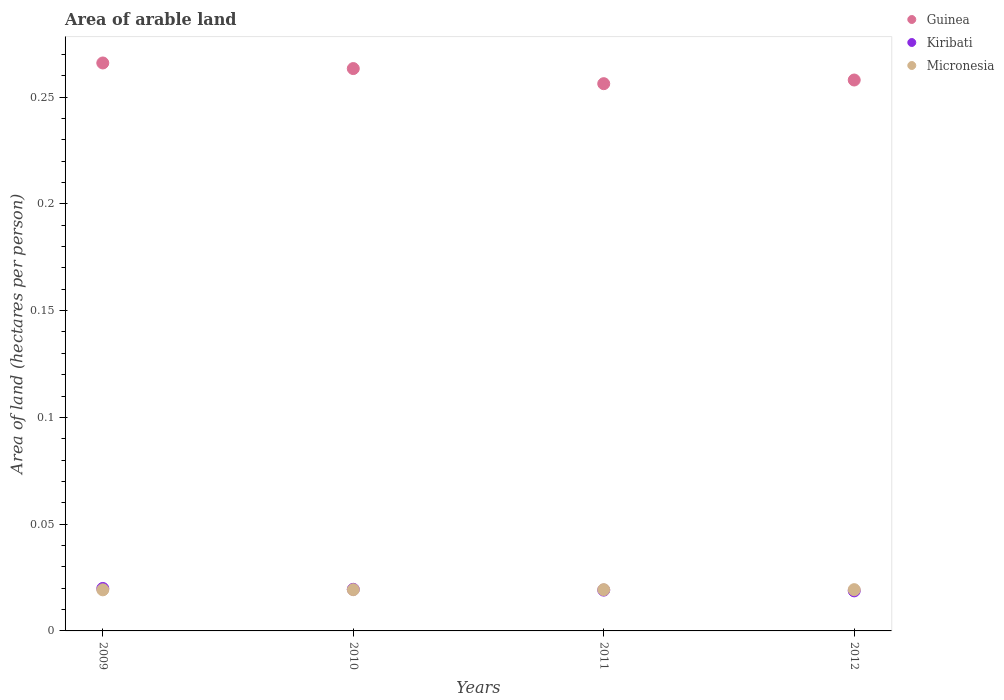Is the number of dotlines equal to the number of legend labels?
Offer a very short reply. Yes. What is the total arable land in Micronesia in 2012?
Your answer should be very brief. 0.02. Across all years, what is the maximum total arable land in Kiribati?
Keep it short and to the point. 0.02. Across all years, what is the minimum total arable land in Kiribati?
Offer a very short reply. 0.02. What is the total total arable land in Guinea in the graph?
Make the answer very short. 1.04. What is the difference between the total arable land in Micronesia in 2010 and that in 2011?
Provide a succinct answer. -2.667392982479838e-5. What is the difference between the total arable land in Micronesia in 2011 and the total arable land in Kiribati in 2012?
Provide a succinct answer. 0. What is the average total arable land in Guinea per year?
Keep it short and to the point. 0.26. In the year 2010, what is the difference between the total arable land in Micronesia and total arable land in Guinea?
Your response must be concise. -0.24. What is the ratio of the total arable land in Micronesia in 2010 to that in 2012?
Your answer should be very brief. 1. What is the difference between the highest and the second highest total arable land in Kiribati?
Provide a succinct answer. 0. What is the difference between the highest and the lowest total arable land in Kiribati?
Give a very brief answer. 0. Is the sum of the total arable land in Guinea in 2010 and 2011 greater than the maximum total arable land in Kiribati across all years?
Give a very brief answer. Yes. Is it the case that in every year, the sum of the total arable land in Kiribati and total arable land in Guinea  is greater than the total arable land in Micronesia?
Your response must be concise. Yes. Is the total arable land in Guinea strictly less than the total arable land in Kiribati over the years?
Ensure brevity in your answer.  No. How many years are there in the graph?
Offer a very short reply. 4. What is the difference between two consecutive major ticks on the Y-axis?
Keep it short and to the point. 0.05. Does the graph contain any zero values?
Offer a very short reply. No. Does the graph contain grids?
Offer a very short reply. No. How many legend labels are there?
Provide a short and direct response. 3. What is the title of the graph?
Your answer should be compact. Area of arable land. Does "Chile" appear as one of the legend labels in the graph?
Keep it short and to the point. No. What is the label or title of the Y-axis?
Your answer should be compact. Area of land (hectares per person). What is the Area of land (hectares per person) of Guinea in 2009?
Provide a succinct answer. 0.27. What is the Area of land (hectares per person) of Kiribati in 2009?
Ensure brevity in your answer.  0.02. What is the Area of land (hectares per person) in Micronesia in 2009?
Provide a succinct answer. 0.02. What is the Area of land (hectares per person) in Guinea in 2010?
Make the answer very short. 0.26. What is the Area of land (hectares per person) in Kiribati in 2010?
Provide a succinct answer. 0.02. What is the Area of land (hectares per person) of Micronesia in 2010?
Keep it short and to the point. 0.02. What is the Area of land (hectares per person) in Guinea in 2011?
Your answer should be very brief. 0.26. What is the Area of land (hectares per person) of Kiribati in 2011?
Provide a short and direct response. 0.02. What is the Area of land (hectares per person) in Micronesia in 2011?
Ensure brevity in your answer.  0.02. What is the Area of land (hectares per person) in Guinea in 2012?
Offer a terse response. 0.26. What is the Area of land (hectares per person) of Kiribati in 2012?
Provide a short and direct response. 0.02. What is the Area of land (hectares per person) in Micronesia in 2012?
Make the answer very short. 0.02. Across all years, what is the maximum Area of land (hectares per person) of Guinea?
Your answer should be very brief. 0.27. Across all years, what is the maximum Area of land (hectares per person) in Kiribati?
Your answer should be compact. 0.02. Across all years, what is the maximum Area of land (hectares per person) of Micronesia?
Give a very brief answer. 0.02. Across all years, what is the minimum Area of land (hectares per person) in Guinea?
Your answer should be compact. 0.26. Across all years, what is the minimum Area of land (hectares per person) of Kiribati?
Provide a succinct answer. 0.02. Across all years, what is the minimum Area of land (hectares per person) in Micronesia?
Keep it short and to the point. 0.02. What is the total Area of land (hectares per person) in Guinea in the graph?
Provide a short and direct response. 1.04. What is the total Area of land (hectares per person) of Kiribati in the graph?
Give a very brief answer. 0.08. What is the total Area of land (hectares per person) in Micronesia in the graph?
Ensure brevity in your answer.  0.08. What is the difference between the Area of land (hectares per person) in Guinea in 2009 and that in 2010?
Provide a succinct answer. 0. What is the difference between the Area of land (hectares per person) of Micronesia in 2009 and that in 2010?
Provide a short and direct response. -0. What is the difference between the Area of land (hectares per person) in Guinea in 2009 and that in 2011?
Offer a terse response. 0.01. What is the difference between the Area of land (hectares per person) of Kiribati in 2009 and that in 2011?
Your answer should be compact. 0. What is the difference between the Area of land (hectares per person) in Micronesia in 2009 and that in 2011?
Provide a short and direct response. -0. What is the difference between the Area of land (hectares per person) in Guinea in 2009 and that in 2012?
Offer a terse response. 0.01. What is the difference between the Area of land (hectares per person) in Kiribati in 2009 and that in 2012?
Provide a short and direct response. 0. What is the difference between the Area of land (hectares per person) in Micronesia in 2009 and that in 2012?
Your response must be concise. -0. What is the difference between the Area of land (hectares per person) of Guinea in 2010 and that in 2011?
Keep it short and to the point. 0.01. What is the difference between the Area of land (hectares per person) of Kiribati in 2010 and that in 2011?
Make the answer very short. 0. What is the difference between the Area of land (hectares per person) in Guinea in 2010 and that in 2012?
Offer a very short reply. 0.01. What is the difference between the Area of land (hectares per person) in Kiribati in 2010 and that in 2012?
Your response must be concise. 0. What is the difference between the Area of land (hectares per person) of Guinea in 2011 and that in 2012?
Your response must be concise. -0. What is the difference between the Area of land (hectares per person) in Kiribati in 2011 and that in 2012?
Provide a succinct answer. 0. What is the difference between the Area of land (hectares per person) of Micronesia in 2011 and that in 2012?
Offer a very short reply. 0. What is the difference between the Area of land (hectares per person) in Guinea in 2009 and the Area of land (hectares per person) in Kiribati in 2010?
Provide a short and direct response. 0.25. What is the difference between the Area of land (hectares per person) of Guinea in 2009 and the Area of land (hectares per person) of Micronesia in 2010?
Your answer should be compact. 0.25. What is the difference between the Area of land (hectares per person) of Kiribati in 2009 and the Area of land (hectares per person) of Micronesia in 2010?
Make the answer very short. 0. What is the difference between the Area of land (hectares per person) in Guinea in 2009 and the Area of land (hectares per person) in Kiribati in 2011?
Give a very brief answer. 0.25. What is the difference between the Area of land (hectares per person) in Guinea in 2009 and the Area of land (hectares per person) in Micronesia in 2011?
Your answer should be compact. 0.25. What is the difference between the Area of land (hectares per person) of Kiribati in 2009 and the Area of land (hectares per person) of Micronesia in 2011?
Provide a succinct answer. 0. What is the difference between the Area of land (hectares per person) in Guinea in 2009 and the Area of land (hectares per person) in Kiribati in 2012?
Provide a succinct answer. 0.25. What is the difference between the Area of land (hectares per person) in Guinea in 2009 and the Area of land (hectares per person) in Micronesia in 2012?
Provide a succinct answer. 0.25. What is the difference between the Area of land (hectares per person) in Kiribati in 2009 and the Area of land (hectares per person) in Micronesia in 2012?
Give a very brief answer. 0. What is the difference between the Area of land (hectares per person) in Guinea in 2010 and the Area of land (hectares per person) in Kiribati in 2011?
Make the answer very short. 0.24. What is the difference between the Area of land (hectares per person) in Guinea in 2010 and the Area of land (hectares per person) in Micronesia in 2011?
Make the answer very short. 0.24. What is the difference between the Area of land (hectares per person) in Guinea in 2010 and the Area of land (hectares per person) in Kiribati in 2012?
Your answer should be compact. 0.24. What is the difference between the Area of land (hectares per person) in Guinea in 2010 and the Area of land (hectares per person) in Micronesia in 2012?
Give a very brief answer. 0.24. What is the difference between the Area of land (hectares per person) in Guinea in 2011 and the Area of land (hectares per person) in Kiribati in 2012?
Give a very brief answer. 0.24. What is the difference between the Area of land (hectares per person) of Guinea in 2011 and the Area of land (hectares per person) of Micronesia in 2012?
Provide a short and direct response. 0.24. What is the difference between the Area of land (hectares per person) in Kiribati in 2011 and the Area of land (hectares per person) in Micronesia in 2012?
Offer a very short reply. -0. What is the average Area of land (hectares per person) in Guinea per year?
Provide a succinct answer. 0.26. What is the average Area of land (hectares per person) in Kiribati per year?
Keep it short and to the point. 0.02. What is the average Area of land (hectares per person) in Micronesia per year?
Provide a short and direct response. 0.02. In the year 2009, what is the difference between the Area of land (hectares per person) of Guinea and Area of land (hectares per person) of Kiribati?
Your response must be concise. 0.25. In the year 2009, what is the difference between the Area of land (hectares per person) in Guinea and Area of land (hectares per person) in Micronesia?
Offer a terse response. 0.25. In the year 2009, what is the difference between the Area of land (hectares per person) of Kiribati and Area of land (hectares per person) of Micronesia?
Provide a short and direct response. 0. In the year 2010, what is the difference between the Area of land (hectares per person) of Guinea and Area of land (hectares per person) of Kiribati?
Ensure brevity in your answer.  0.24. In the year 2010, what is the difference between the Area of land (hectares per person) in Guinea and Area of land (hectares per person) in Micronesia?
Ensure brevity in your answer.  0.24. In the year 2010, what is the difference between the Area of land (hectares per person) of Kiribati and Area of land (hectares per person) of Micronesia?
Provide a succinct answer. 0. In the year 2011, what is the difference between the Area of land (hectares per person) in Guinea and Area of land (hectares per person) in Kiribati?
Provide a short and direct response. 0.24. In the year 2011, what is the difference between the Area of land (hectares per person) of Guinea and Area of land (hectares per person) of Micronesia?
Provide a succinct answer. 0.24. In the year 2011, what is the difference between the Area of land (hectares per person) in Kiribati and Area of land (hectares per person) in Micronesia?
Your answer should be compact. -0. In the year 2012, what is the difference between the Area of land (hectares per person) in Guinea and Area of land (hectares per person) in Kiribati?
Offer a very short reply. 0.24. In the year 2012, what is the difference between the Area of land (hectares per person) of Guinea and Area of land (hectares per person) of Micronesia?
Provide a succinct answer. 0.24. In the year 2012, what is the difference between the Area of land (hectares per person) in Kiribati and Area of land (hectares per person) in Micronesia?
Provide a succinct answer. -0. What is the ratio of the Area of land (hectares per person) of Kiribati in 2009 to that in 2010?
Your answer should be very brief. 1.02. What is the ratio of the Area of land (hectares per person) of Guinea in 2009 to that in 2011?
Offer a terse response. 1.04. What is the ratio of the Area of land (hectares per person) in Kiribati in 2009 to that in 2011?
Keep it short and to the point. 1.04. What is the ratio of the Area of land (hectares per person) in Guinea in 2009 to that in 2012?
Provide a short and direct response. 1.03. What is the ratio of the Area of land (hectares per person) of Kiribati in 2009 to that in 2012?
Keep it short and to the point. 1.06. What is the ratio of the Area of land (hectares per person) of Micronesia in 2009 to that in 2012?
Make the answer very short. 1. What is the ratio of the Area of land (hectares per person) in Guinea in 2010 to that in 2011?
Offer a very short reply. 1.03. What is the ratio of the Area of land (hectares per person) in Kiribati in 2010 to that in 2011?
Your answer should be very brief. 1.02. What is the ratio of the Area of land (hectares per person) in Micronesia in 2010 to that in 2011?
Give a very brief answer. 1. What is the ratio of the Area of land (hectares per person) in Guinea in 2010 to that in 2012?
Keep it short and to the point. 1.02. What is the ratio of the Area of land (hectares per person) of Kiribati in 2010 to that in 2012?
Keep it short and to the point. 1.04. What is the ratio of the Area of land (hectares per person) in Micronesia in 2010 to that in 2012?
Offer a terse response. 1. What is the ratio of the Area of land (hectares per person) in Guinea in 2011 to that in 2012?
Your answer should be very brief. 0.99. What is the ratio of the Area of land (hectares per person) in Kiribati in 2011 to that in 2012?
Provide a succinct answer. 1.02. What is the difference between the highest and the second highest Area of land (hectares per person) in Guinea?
Your response must be concise. 0. What is the difference between the highest and the second highest Area of land (hectares per person) of Kiribati?
Ensure brevity in your answer.  0. What is the difference between the highest and the lowest Area of land (hectares per person) of Guinea?
Offer a terse response. 0.01. What is the difference between the highest and the lowest Area of land (hectares per person) in Kiribati?
Your answer should be compact. 0. 